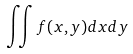Convert formula to latex. <formula><loc_0><loc_0><loc_500><loc_500>\iint f ( x , y ) d x d y</formula> 